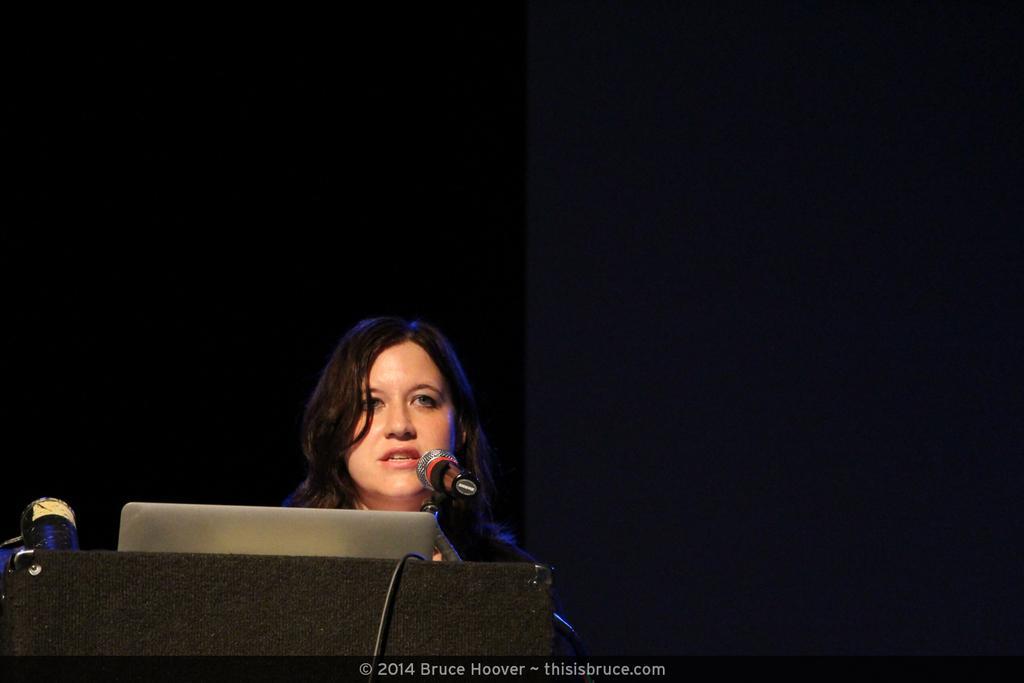Could you give a brief overview of what you see in this image? As we can see in the image there is a laptop, mic and a woman standing over here. The image is little dark. 